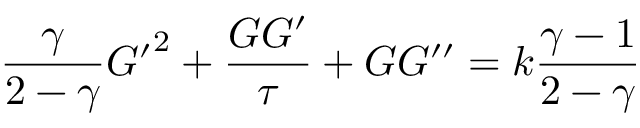Convert formula to latex. <formula><loc_0><loc_0><loc_500><loc_500>{ \frac { \gamma } { 2 - \gamma } } { G ^ { \prime } } ^ { 2 } + { \frac { G G ^ { \prime } } { \tau } } + G G ^ { \prime \prime } = k { \frac { \gamma - 1 } { 2 - \gamma } }</formula> 